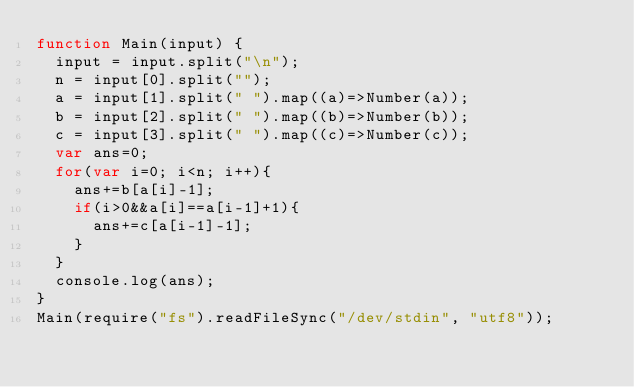<code> <loc_0><loc_0><loc_500><loc_500><_JavaScript_>function Main(input) {
  input = input.split("\n");
  n = input[0].split("");
  a = input[1].split(" ").map((a)=>Number(a));
  b = input[2].split(" ").map((b)=>Number(b));
  c = input[3].split(" ").map((c)=>Number(c));
  var ans=0;
  for(var i=0; i<n; i++){
    ans+=b[a[i]-1];
    if(i>0&&a[i]==a[i-1]+1){
      ans+=c[a[i-1]-1];
    }
  }
  console.log(ans);
}
Main(require("fs").readFileSync("/dev/stdin", "utf8"));</code> 